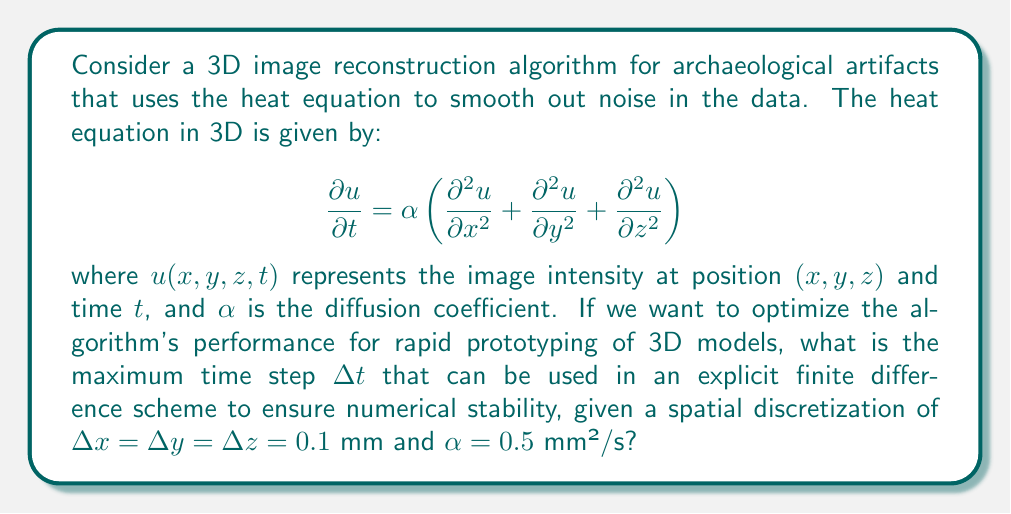What is the answer to this math problem? To determine the maximum time step for numerical stability in an explicit finite difference scheme for the 3D heat equation, we need to consider the Courant-Friedrichs-Lewy (CFL) condition.

For the 3D heat equation, the CFL condition states that:

$$\frac{\alpha \Delta t}{(\Delta x)^2} + \frac{\alpha \Delta t}{(\Delta y)^2} + \frac{\alpha \Delta t}{(\Delta z)^2} \leq \frac{1}{2}$$

Given that $\Delta x = \Delta y = \Delta z = 0.1$ mm, we can simplify this to:

$$3\frac{\alpha \Delta t}{(\Delta x)^2} \leq \frac{1}{2}$$

Substituting the given values:

$$3\frac{0.5 \Delta t}{(0.1)^2} \leq \frac{1}{2}$$

Simplifying:

$$\frac{150 \Delta t}{1} \leq \frac{1}{2}$$

Solving for $\Delta t$:

$$\Delta t \leq \frac{1}{300}$$

Therefore, the maximum time step that ensures numerical stability is:

$$\Delta t = \frac{1}{300} \text{ s} = 0.00333... \text{ s}$$
Answer: The maximum time step $\Delta t$ for numerical stability is $\frac{1}{300}$ seconds or approximately 0.00333 seconds. 